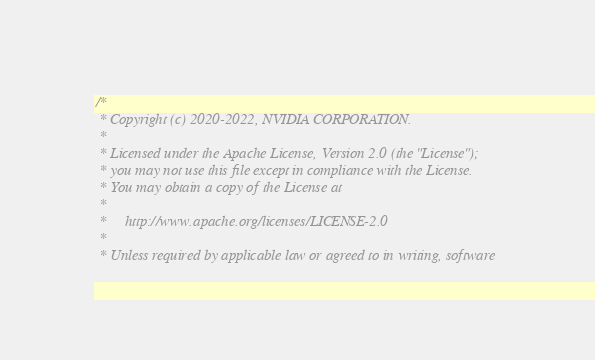<code> <loc_0><loc_0><loc_500><loc_500><_Cuda_>/*
 * Copyright (c) 2020-2022, NVIDIA CORPORATION.
 *
 * Licensed under the Apache License, Version 2.0 (the "License");
 * you may not use this file except in compliance with the License.
 * You may obtain a copy of the License at
 *
 *     http://www.apache.org/licenses/LICENSE-2.0
 *
 * Unless required by applicable law or agreed to in writing, software</code> 